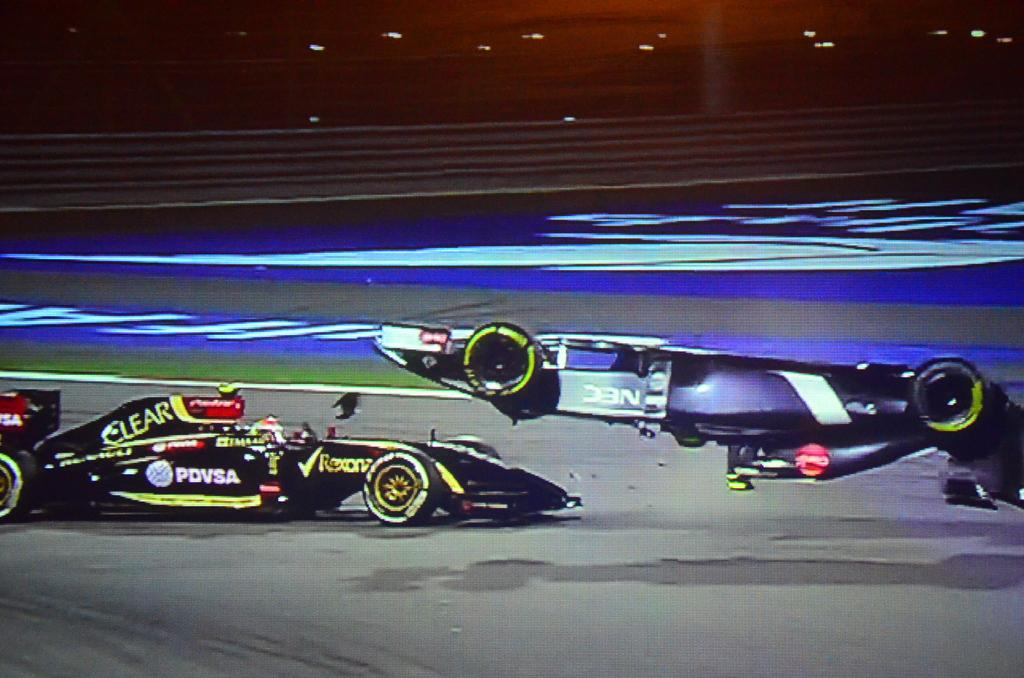<image>
Render a clear and concise summary of the photo. The Rexona car is next to another race car which has flipped upside down. 